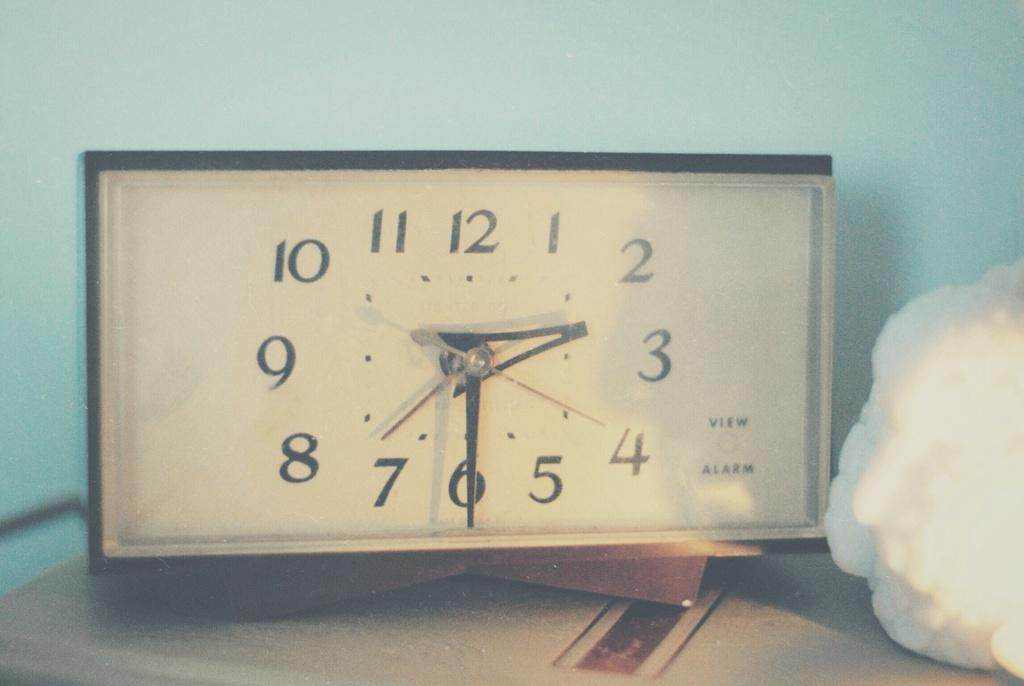<image>
Relay a brief, clear account of the picture shown. Square clock with the hands on the numbers  3 and 6. 